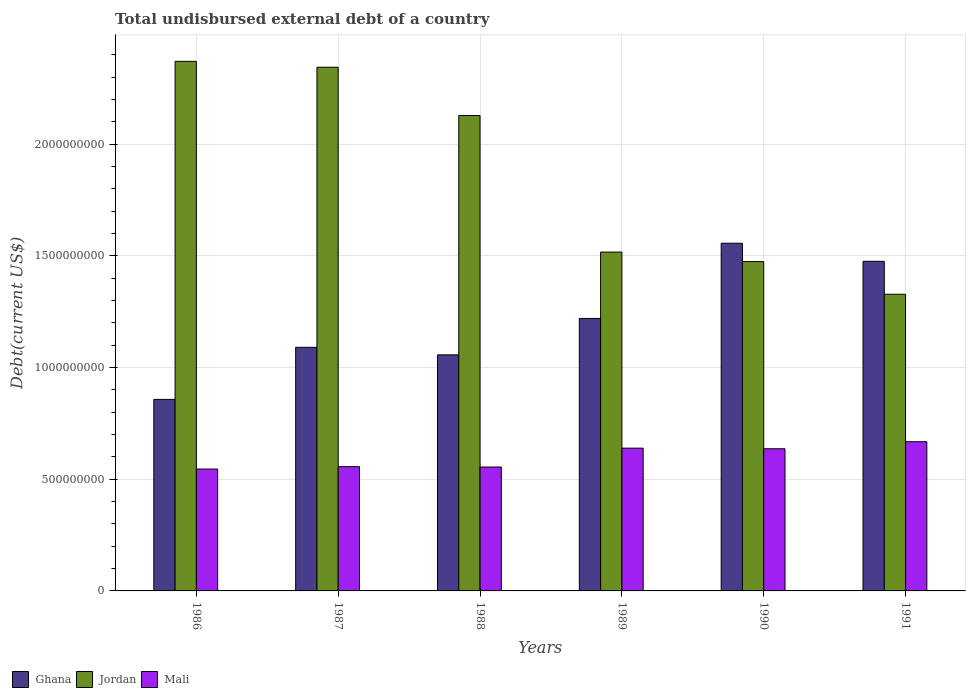How many different coloured bars are there?
Offer a terse response. 3. How many groups of bars are there?
Your response must be concise. 6. How many bars are there on the 4th tick from the left?
Make the answer very short. 3. How many bars are there on the 1st tick from the right?
Your answer should be very brief. 3. In how many cases, is the number of bars for a given year not equal to the number of legend labels?
Offer a very short reply. 0. What is the total undisbursed external debt in Ghana in 1986?
Provide a short and direct response. 8.58e+08. Across all years, what is the maximum total undisbursed external debt in Jordan?
Provide a succinct answer. 2.37e+09. Across all years, what is the minimum total undisbursed external debt in Ghana?
Your answer should be very brief. 8.58e+08. In which year was the total undisbursed external debt in Mali minimum?
Your answer should be compact. 1986. What is the total total undisbursed external debt in Ghana in the graph?
Give a very brief answer. 7.26e+09. What is the difference between the total undisbursed external debt in Ghana in 1988 and that in 1989?
Offer a very short reply. -1.63e+08. What is the difference between the total undisbursed external debt in Ghana in 1987 and the total undisbursed external debt in Jordan in 1989?
Keep it short and to the point. -4.26e+08. What is the average total undisbursed external debt in Jordan per year?
Ensure brevity in your answer.  1.86e+09. In the year 1990, what is the difference between the total undisbursed external debt in Mali and total undisbursed external debt in Ghana?
Your response must be concise. -9.20e+08. What is the ratio of the total undisbursed external debt in Mali in 1988 to that in 1990?
Your response must be concise. 0.87. Is the difference between the total undisbursed external debt in Mali in 1989 and 1990 greater than the difference between the total undisbursed external debt in Ghana in 1989 and 1990?
Offer a very short reply. Yes. What is the difference between the highest and the second highest total undisbursed external debt in Ghana?
Ensure brevity in your answer.  8.10e+07. What is the difference between the highest and the lowest total undisbursed external debt in Ghana?
Offer a very short reply. 6.99e+08. What does the 2nd bar from the left in 1991 represents?
Your answer should be compact. Jordan. How many years are there in the graph?
Make the answer very short. 6. Are the values on the major ticks of Y-axis written in scientific E-notation?
Your answer should be compact. No. Does the graph contain any zero values?
Make the answer very short. No. Does the graph contain grids?
Make the answer very short. Yes. What is the title of the graph?
Offer a terse response. Total undisbursed external debt of a country. What is the label or title of the X-axis?
Give a very brief answer. Years. What is the label or title of the Y-axis?
Offer a terse response. Debt(current US$). What is the Debt(current US$) in Ghana in 1986?
Offer a very short reply. 8.58e+08. What is the Debt(current US$) of Jordan in 1986?
Offer a very short reply. 2.37e+09. What is the Debt(current US$) of Mali in 1986?
Your answer should be very brief. 5.46e+08. What is the Debt(current US$) of Ghana in 1987?
Provide a succinct answer. 1.09e+09. What is the Debt(current US$) in Jordan in 1987?
Offer a terse response. 2.34e+09. What is the Debt(current US$) in Mali in 1987?
Give a very brief answer. 5.56e+08. What is the Debt(current US$) in Ghana in 1988?
Make the answer very short. 1.06e+09. What is the Debt(current US$) in Jordan in 1988?
Make the answer very short. 2.13e+09. What is the Debt(current US$) of Mali in 1988?
Offer a very short reply. 5.55e+08. What is the Debt(current US$) in Ghana in 1989?
Provide a short and direct response. 1.22e+09. What is the Debt(current US$) in Jordan in 1989?
Your answer should be compact. 1.52e+09. What is the Debt(current US$) in Mali in 1989?
Provide a succinct answer. 6.39e+08. What is the Debt(current US$) of Ghana in 1990?
Provide a short and direct response. 1.56e+09. What is the Debt(current US$) of Jordan in 1990?
Ensure brevity in your answer.  1.47e+09. What is the Debt(current US$) of Mali in 1990?
Keep it short and to the point. 6.37e+08. What is the Debt(current US$) of Ghana in 1991?
Offer a very short reply. 1.48e+09. What is the Debt(current US$) of Jordan in 1991?
Keep it short and to the point. 1.33e+09. What is the Debt(current US$) of Mali in 1991?
Your answer should be very brief. 6.68e+08. Across all years, what is the maximum Debt(current US$) of Ghana?
Give a very brief answer. 1.56e+09. Across all years, what is the maximum Debt(current US$) of Jordan?
Your answer should be compact. 2.37e+09. Across all years, what is the maximum Debt(current US$) in Mali?
Give a very brief answer. 6.68e+08. Across all years, what is the minimum Debt(current US$) of Ghana?
Provide a succinct answer. 8.58e+08. Across all years, what is the minimum Debt(current US$) of Jordan?
Your answer should be compact. 1.33e+09. Across all years, what is the minimum Debt(current US$) in Mali?
Keep it short and to the point. 5.46e+08. What is the total Debt(current US$) in Ghana in the graph?
Your response must be concise. 7.26e+09. What is the total Debt(current US$) of Jordan in the graph?
Keep it short and to the point. 1.12e+1. What is the total Debt(current US$) in Mali in the graph?
Make the answer very short. 3.60e+09. What is the difference between the Debt(current US$) in Ghana in 1986 and that in 1987?
Your response must be concise. -2.33e+08. What is the difference between the Debt(current US$) in Jordan in 1986 and that in 1987?
Keep it short and to the point. 2.63e+07. What is the difference between the Debt(current US$) of Mali in 1986 and that in 1987?
Provide a succinct answer. -1.07e+07. What is the difference between the Debt(current US$) in Ghana in 1986 and that in 1988?
Provide a short and direct response. -1.99e+08. What is the difference between the Debt(current US$) of Jordan in 1986 and that in 1988?
Ensure brevity in your answer.  2.43e+08. What is the difference between the Debt(current US$) in Mali in 1986 and that in 1988?
Provide a short and direct response. -9.05e+06. What is the difference between the Debt(current US$) in Ghana in 1986 and that in 1989?
Your response must be concise. -3.62e+08. What is the difference between the Debt(current US$) in Jordan in 1986 and that in 1989?
Make the answer very short. 8.54e+08. What is the difference between the Debt(current US$) of Mali in 1986 and that in 1989?
Provide a succinct answer. -9.35e+07. What is the difference between the Debt(current US$) in Ghana in 1986 and that in 1990?
Offer a very short reply. -6.99e+08. What is the difference between the Debt(current US$) in Jordan in 1986 and that in 1990?
Give a very brief answer. 8.97e+08. What is the difference between the Debt(current US$) of Mali in 1986 and that in 1990?
Make the answer very short. -9.09e+07. What is the difference between the Debt(current US$) in Ghana in 1986 and that in 1991?
Ensure brevity in your answer.  -6.18e+08. What is the difference between the Debt(current US$) in Jordan in 1986 and that in 1991?
Offer a terse response. 1.04e+09. What is the difference between the Debt(current US$) of Mali in 1986 and that in 1991?
Offer a terse response. -1.22e+08. What is the difference between the Debt(current US$) of Ghana in 1987 and that in 1988?
Offer a terse response. 3.37e+07. What is the difference between the Debt(current US$) in Jordan in 1987 and that in 1988?
Keep it short and to the point. 2.16e+08. What is the difference between the Debt(current US$) in Mali in 1987 and that in 1988?
Ensure brevity in your answer.  1.64e+06. What is the difference between the Debt(current US$) of Ghana in 1987 and that in 1989?
Keep it short and to the point. -1.29e+08. What is the difference between the Debt(current US$) of Jordan in 1987 and that in 1989?
Provide a short and direct response. 8.28e+08. What is the difference between the Debt(current US$) of Mali in 1987 and that in 1989?
Provide a short and direct response. -8.28e+07. What is the difference between the Debt(current US$) in Ghana in 1987 and that in 1990?
Provide a short and direct response. -4.66e+08. What is the difference between the Debt(current US$) in Jordan in 1987 and that in 1990?
Provide a short and direct response. 8.70e+08. What is the difference between the Debt(current US$) in Mali in 1987 and that in 1990?
Offer a very short reply. -8.02e+07. What is the difference between the Debt(current US$) in Ghana in 1987 and that in 1991?
Offer a terse response. -3.85e+08. What is the difference between the Debt(current US$) of Jordan in 1987 and that in 1991?
Provide a succinct answer. 1.02e+09. What is the difference between the Debt(current US$) in Mali in 1987 and that in 1991?
Offer a terse response. -1.12e+08. What is the difference between the Debt(current US$) in Ghana in 1988 and that in 1989?
Your answer should be compact. -1.63e+08. What is the difference between the Debt(current US$) in Jordan in 1988 and that in 1989?
Your answer should be compact. 6.11e+08. What is the difference between the Debt(current US$) of Mali in 1988 and that in 1989?
Your answer should be very brief. -8.45e+07. What is the difference between the Debt(current US$) in Ghana in 1988 and that in 1990?
Make the answer very short. -5.00e+08. What is the difference between the Debt(current US$) of Jordan in 1988 and that in 1990?
Your answer should be very brief. 6.54e+08. What is the difference between the Debt(current US$) of Mali in 1988 and that in 1990?
Your answer should be compact. -8.18e+07. What is the difference between the Debt(current US$) of Ghana in 1988 and that in 1991?
Ensure brevity in your answer.  -4.19e+08. What is the difference between the Debt(current US$) in Jordan in 1988 and that in 1991?
Ensure brevity in your answer.  8.00e+08. What is the difference between the Debt(current US$) of Mali in 1988 and that in 1991?
Offer a very short reply. -1.13e+08. What is the difference between the Debt(current US$) of Ghana in 1989 and that in 1990?
Provide a succinct answer. -3.37e+08. What is the difference between the Debt(current US$) of Jordan in 1989 and that in 1990?
Your answer should be very brief. 4.27e+07. What is the difference between the Debt(current US$) in Mali in 1989 and that in 1990?
Offer a very short reply. 2.66e+06. What is the difference between the Debt(current US$) of Ghana in 1989 and that in 1991?
Your answer should be very brief. -2.56e+08. What is the difference between the Debt(current US$) of Jordan in 1989 and that in 1991?
Keep it short and to the point. 1.89e+08. What is the difference between the Debt(current US$) of Mali in 1989 and that in 1991?
Your answer should be compact. -2.88e+07. What is the difference between the Debt(current US$) of Ghana in 1990 and that in 1991?
Give a very brief answer. 8.10e+07. What is the difference between the Debt(current US$) in Jordan in 1990 and that in 1991?
Ensure brevity in your answer.  1.46e+08. What is the difference between the Debt(current US$) in Mali in 1990 and that in 1991?
Your answer should be very brief. -3.14e+07. What is the difference between the Debt(current US$) in Ghana in 1986 and the Debt(current US$) in Jordan in 1987?
Make the answer very short. -1.49e+09. What is the difference between the Debt(current US$) of Ghana in 1986 and the Debt(current US$) of Mali in 1987?
Offer a very short reply. 3.01e+08. What is the difference between the Debt(current US$) of Jordan in 1986 and the Debt(current US$) of Mali in 1987?
Your response must be concise. 1.81e+09. What is the difference between the Debt(current US$) in Ghana in 1986 and the Debt(current US$) in Jordan in 1988?
Keep it short and to the point. -1.27e+09. What is the difference between the Debt(current US$) in Ghana in 1986 and the Debt(current US$) in Mali in 1988?
Offer a terse response. 3.03e+08. What is the difference between the Debt(current US$) in Jordan in 1986 and the Debt(current US$) in Mali in 1988?
Offer a terse response. 1.82e+09. What is the difference between the Debt(current US$) of Ghana in 1986 and the Debt(current US$) of Jordan in 1989?
Your answer should be very brief. -6.60e+08. What is the difference between the Debt(current US$) of Ghana in 1986 and the Debt(current US$) of Mali in 1989?
Provide a succinct answer. 2.18e+08. What is the difference between the Debt(current US$) in Jordan in 1986 and the Debt(current US$) in Mali in 1989?
Provide a succinct answer. 1.73e+09. What is the difference between the Debt(current US$) in Ghana in 1986 and the Debt(current US$) in Jordan in 1990?
Offer a very short reply. -6.17e+08. What is the difference between the Debt(current US$) of Ghana in 1986 and the Debt(current US$) of Mali in 1990?
Ensure brevity in your answer.  2.21e+08. What is the difference between the Debt(current US$) of Jordan in 1986 and the Debt(current US$) of Mali in 1990?
Provide a succinct answer. 1.73e+09. What is the difference between the Debt(current US$) in Ghana in 1986 and the Debt(current US$) in Jordan in 1991?
Offer a very short reply. -4.71e+08. What is the difference between the Debt(current US$) in Ghana in 1986 and the Debt(current US$) in Mali in 1991?
Ensure brevity in your answer.  1.90e+08. What is the difference between the Debt(current US$) in Jordan in 1986 and the Debt(current US$) in Mali in 1991?
Ensure brevity in your answer.  1.70e+09. What is the difference between the Debt(current US$) of Ghana in 1987 and the Debt(current US$) of Jordan in 1988?
Your response must be concise. -1.04e+09. What is the difference between the Debt(current US$) of Ghana in 1987 and the Debt(current US$) of Mali in 1988?
Your answer should be very brief. 5.36e+08. What is the difference between the Debt(current US$) in Jordan in 1987 and the Debt(current US$) in Mali in 1988?
Your answer should be very brief. 1.79e+09. What is the difference between the Debt(current US$) in Ghana in 1987 and the Debt(current US$) in Jordan in 1989?
Provide a succinct answer. -4.26e+08. What is the difference between the Debt(current US$) of Ghana in 1987 and the Debt(current US$) of Mali in 1989?
Offer a terse response. 4.51e+08. What is the difference between the Debt(current US$) of Jordan in 1987 and the Debt(current US$) of Mali in 1989?
Ensure brevity in your answer.  1.71e+09. What is the difference between the Debt(current US$) in Ghana in 1987 and the Debt(current US$) in Jordan in 1990?
Your answer should be very brief. -3.84e+08. What is the difference between the Debt(current US$) in Ghana in 1987 and the Debt(current US$) in Mali in 1990?
Offer a terse response. 4.54e+08. What is the difference between the Debt(current US$) in Jordan in 1987 and the Debt(current US$) in Mali in 1990?
Provide a succinct answer. 1.71e+09. What is the difference between the Debt(current US$) in Ghana in 1987 and the Debt(current US$) in Jordan in 1991?
Provide a short and direct response. -2.38e+08. What is the difference between the Debt(current US$) of Ghana in 1987 and the Debt(current US$) of Mali in 1991?
Provide a short and direct response. 4.23e+08. What is the difference between the Debt(current US$) in Jordan in 1987 and the Debt(current US$) in Mali in 1991?
Keep it short and to the point. 1.68e+09. What is the difference between the Debt(current US$) in Ghana in 1988 and the Debt(current US$) in Jordan in 1989?
Your response must be concise. -4.60e+08. What is the difference between the Debt(current US$) of Ghana in 1988 and the Debt(current US$) of Mali in 1989?
Offer a terse response. 4.18e+08. What is the difference between the Debt(current US$) in Jordan in 1988 and the Debt(current US$) in Mali in 1989?
Keep it short and to the point. 1.49e+09. What is the difference between the Debt(current US$) in Ghana in 1988 and the Debt(current US$) in Jordan in 1990?
Your response must be concise. -4.17e+08. What is the difference between the Debt(current US$) of Ghana in 1988 and the Debt(current US$) of Mali in 1990?
Provide a succinct answer. 4.20e+08. What is the difference between the Debt(current US$) in Jordan in 1988 and the Debt(current US$) in Mali in 1990?
Your response must be concise. 1.49e+09. What is the difference between the Debt(current US$) in Ghana in 1988 and the Debt(current US$) in Jordan in 1991?
Make the answer very short. -2.71e+08. What is the difference between the Debt(current US$) of Ghana in 1988 and the Debt(current US$) of Mali in 1991?
Make the answer very short. 3.89e+08. What is the difference between the Debt(current US$) of Jordan in 1988 and the Debt(current US$) of Mali in 1991?
Your answer should be very brief. 1.46e+09. What is the difference between the Debt(current US$) of Ghana in 1989 and the Debt(current US$) of Jordan in 1990?
Give a very brief answer. -2.55e+08. What is the difference between the Debt(current US$) of Ghana in 1989 and the Debt(current US$) of Mali in 1990?
Provide a short and direct response. 5.83e+08. What is the difference between the Debt(current US$) of Jordan in 1989 and the Debt(current US$) of Mali in 1990?
Provide a succinct answer. 8.81e+08. What is the difference between the Debt(current US$) in Ghana in 1989 and the Debt(current US$) in Jordan in 1991?
Give a very brief answer. -1.08e+08. What is the difference between the Debt(current US$) of Ghana in 1989 and the Debt(current US$) of Mali in 1991?
Your answer should be compact. 5.52e+08. What is the difference between the Debt(current US$) of Jordan in 1989 and the Debt(current US$) of Mali in 1991?
Provide a short and direct response. 8.49e+08. What is the difference between the Debt(current US$) of Ghana in 1990 and the Debt(current US$) of Jordan in 1991?
Offer a terse response. 2.29e+08. What is the difference between the Debt(current US$) in Ghana in 1990 and the Debt(current US$) in Mali in 1991?
Give a very brief answer. 8.89e+08. What is the difference between the Debt(current US$) of Jordan in 1990 and the Debt(current US$) of Mali in 1991?
Keep it short and to the point. 8.06e+08. What is the average Debt(current US$) of Ghana per year?
Keep it short and to the point. 1.21e+09. What is the average Debt(current US$) of Jordan per year?
Give a very brief answer. 1.86e+09. What is the average Debt(current US$) of Mali per year?
Offer a terse response. 6.00e+08. In the year 1986, what is the difference between the Debt(current US$) of Ghana and Debt(current US$) of Jordan?
Keep it short and to the point. -1.51e+09. In the year 1986, what is the difference between the Debt(current US$) of Ghana and Debt(current US$) of Mali?
Make the answer very short. 3.12e+08. In the year 1986, what is the difference between the Debt(current US$) in Jordan and Debt(current US$) in Mali?
Your answer should be very brief. 1.83e+09. In the year 1987, what is the difference between the Debt(current US$) in Ghana and Debt(current US$) in Jordan?
Your answer should be very brief. -1.25e+09. In the year 1987, what is the difference between the Debt(current US$) of Ghana and Debt(current US$) of Mali?
Keep it short and to the point. 5.34e+08. In the year 1987, what is the difference between the Debt(current US$) of Jordan and Debt(current US$) of Mali?
Your response must be concise. 1.79e+09. In the year 1988, what is the difference between the Debt(current US$) in Ghana and Debt(current US$) in Jordan?
Provide a short and direct response. -1.07e+09. In the year 1988, what is the difference between the Debt(current US$) of Ghana and Debt(current US$) of Mali?
Your answer should be compact. 5.02e+08. In the year 1988, what is the difference between the Debt(current US$) of Jordan and Debt(current US$) of Mali?
Offer a terse response. 1.57e+09. In the year 1989, what is the difference between the Debt(current US$) in Ghana and Debt(current US$) in Jordan?
Give a very brief answer. -2.97e+08. In the year 1989, what is the difference between the Debt(current US$) of Ghana and Debt(current US$) of Mali?
Keep it short and to the point. 5.81e+08. In the year 1989, what is the difference between the Debt(current US$) of Jordan and Debt(current US$) of Mali?
Your answer should be compact. 8.78e+08. In the year 1990, what is the difference between the Debt(current US$) of Ghana and Debt(current US$) of Jordan?
Keep it short and to the point. 8.23e+07. In the year 1990, what is the difference between the Debt(current US$) in Ghana and Debt(current US$) in Mali?
Your answer should be compact. 9.20e+08. In the year 1990, what is the difference between the Debt(current US$) in Jordan and Debt(current US$) in Mali?
Provide a succinct answer. 8.38e+08. In the year 1991, what is the difference between the Debt(current US$) of Ghana and Debt(current US$) of Jordan?
Your answer should be compact. 1.48e+08. In the year 1991, what is the difference between the Debt(current US$) of Ghana and Debt(current US$) of Mali?
Your response must be concise. 8.08e+08. In the year 1991, what is the difference between the Debt(current US$) in Jordan and Debt(current US$) in Mali?
Offer a very short reply. 6.60e+08. What is the ratio of the Debt(current US$) in Ghana in 1986 to that in 1987?
Ensure brevity in your answer.  0.79. What is the ratio of the Debt(current US$) of Jordan in 1986 to that in 1987?
Offer a very short reply. 1.01. What is the ratio of the Debt(current US$) of Mali in 1986 to that in 1987?
Offer a very short reply. 0.98. What is the ratio of the Debt(current US$) of Ghana in 1986 to that in 1988?
Your answer should be very brief. 0.81. What is the ratio of the Debt(current US$) in Jordan in 1986 to that in 1988?
Ensure brevity in your answer.  1.11. What is the ratio of the Debt(current US$) in Mali in 1986 to that in 1988?
Offer a terse response. 0.98. What is the ratio of the Debt(current US$) in Ghana in 1986 to that in 1989?
Offer a very short reply. 0.7. What is the ratio of the Debt(current US$) in Jordan in 1986 to that in 1989?
Provide a short and direct response. 1.56. What is the ratio of the Debt(current US$) of Mali in 1986 to that in 1989?
Provide a succinct answer. 0.85. What is the ratio of the Debt(current US$) in Ghana in 1986 to that in 1990?
Your answer should be compact. 0.55. What is the ratio of the Debt(current US$) of Jordan in 1986 to that in 1990?
Offer a very short reply. 1.61. What is the ratio of the Debt(current US$) in Mali in 1986 to that in 1990?
Ensure brevity in your answer.  0.86. What is the ratio of the Debt(current US$) in Ghana in 1986 to that in 1991?
Your answer should be compact. 0.58. What is the ratio of the Debt(current US$) in Jordan in 1986 to that in 1991?
Keep it short and to the point. 1.79. What is the ratio of the Debt(current US$) in Mali in 1986 to that in 1991?
Keep it short and to the point. 0.82. What is the ratio of the Debt(current US$) in Ghana in 1987 to that in 1988?
Offer a terse response. 1.03. What is the ratio of the Debt(current US$) of Jordan in 1987 to that in 1988?
Offer a terse response. 1.1. What is the ratio of the Debt(current US$) in Ghana in 1987 to that in 1989?
Offer a very short reply. 0.89. What is the ratio of the Debt(current US$) of Jordan in 1987 to that in 1989?
Provide a succinct answer. 1.55. What is the ratio of the Debt(current US$) of Mali in 1987 to that in 1989?
Offer a terse response. 0.87. What is the ratio of the Debt(current US$) in Ghana in 1987 to that in 1990?
Your response must be concise. 0.7. What is the ratio of the Debt(current US$) of Jordan in 1987 to that in 1990?
Provide a short and direct response. 1.59. What is the ratio of the Debt(current US$) of Mali in 1987 to that in 1990?
Give a very brief answer. 0.87. What is the ratio of the Debt(current US$) in Ghana in 1987 to that in 1991?
Ensure brevity in your answer.  0.74. What is the ratio of the Debt(current US$) in Jordan in 1987 to that in 1991?
Provide a succinct answer. 1.77. What is the ratio of the Debt(current US$) in Mali in 1987 to that in 1991?
Offer a very short reply. 0.83. What is the ratio of the Debt(current US$) in Ghana in 1988 to that in 1989?
Your answer should be compact. 0.87. What is the ratio of the Debt(current US$) in Jordan in 1988 to that in 1989?
Your response must be concise. 1.4. What is the ratio of the Debt(current US$) in Mali in 1988 to that in 1989?
Your answer should be very brief. 0.87. What is the ratio of the Debt(current US$) in Ghana in 1988 to that in 1990?
Offer a terse response. 0.68. What is the ratio of the Debt(current US$) in Jordan in 1988 to that in 1990?
Offer a very short reply. 1.44. What is the ratio of the Debt(current US$) of Mali in 1988 to that in 1990?
Your response must be concise. 0.87. What is the ratio of the Debt(current US$) in Ghana in 1988 to that in 1991?
Your answer should be very brief. 0.72. What is the ratio of the Debt(current US$) in Jordan in 1988 to that in 1991?
Keep it short and to the point. 1.6. What is the ratio of the Debt(current US$) of Mali in 1988 to that in 1991?
Your response must be concise. 0.83. What is the ratio of the Debt(current US$) of Ghana in 1989 to that in 1990?
Give a very brief answer. 0.78. What is the ratio of the Debt(current US$) in Jordan in 1989 to that in 1990?
Give a very brief answer. 1.03. What is the ratio of the Debt(current US$) of Mali in 1989 to that in 1990?
Keep it short and to the point. 1. What is the ratio of the Debt(current US$) of Ghana in 1989 to that in 1991?
Offer a terse response. 0.83. What is the ratio of the Debt(current US$) of Jordan in 1989 to that in 1991?
Give a very brief answer. 1.14. What is the ratio of the Debt(current US$) of Mali in 1989 to that in 1991?
Your answer should be very brief. 0.96. What is the ratio of the Debt(current US$) of Ghana in 1990 to that in 1991?
Your answer should be very brief. 1.05. What is the ratio of the Debt(current US$) in Jordan in 1990 to that in 1991?
Your answer should be compact. 1.11. What is the ratio of the Debt(current US$) in Mali in 1990 to that in 1991?
Keep it short and to the point. 0.95. What is the difference between the highest and the second highest Debt(current US$) in Ghana?
Ensure brevity in your answer.  8.10e+07. What is the difference between the highest and the second highest Debt(current US$) of Jordan?
Give a very brief answer. 2.63e+07. What is the difference between the highest and the second highest Debt(current US$) in Mali?
Make the answer very short. 2.88e+07. What is the difference between the highest and the lowest Debt(current US$) in Ghana?
Give a very brief answer. 6.99e+08. What is the difference between the highest and the lowest Debt(current US$) in Jordan?
Your response must be concise. 1.04e+09. What is the difference between the highest and the lowest Debt(current US$) of Mali?
Your answer should be very brief. 1.22e+08. 